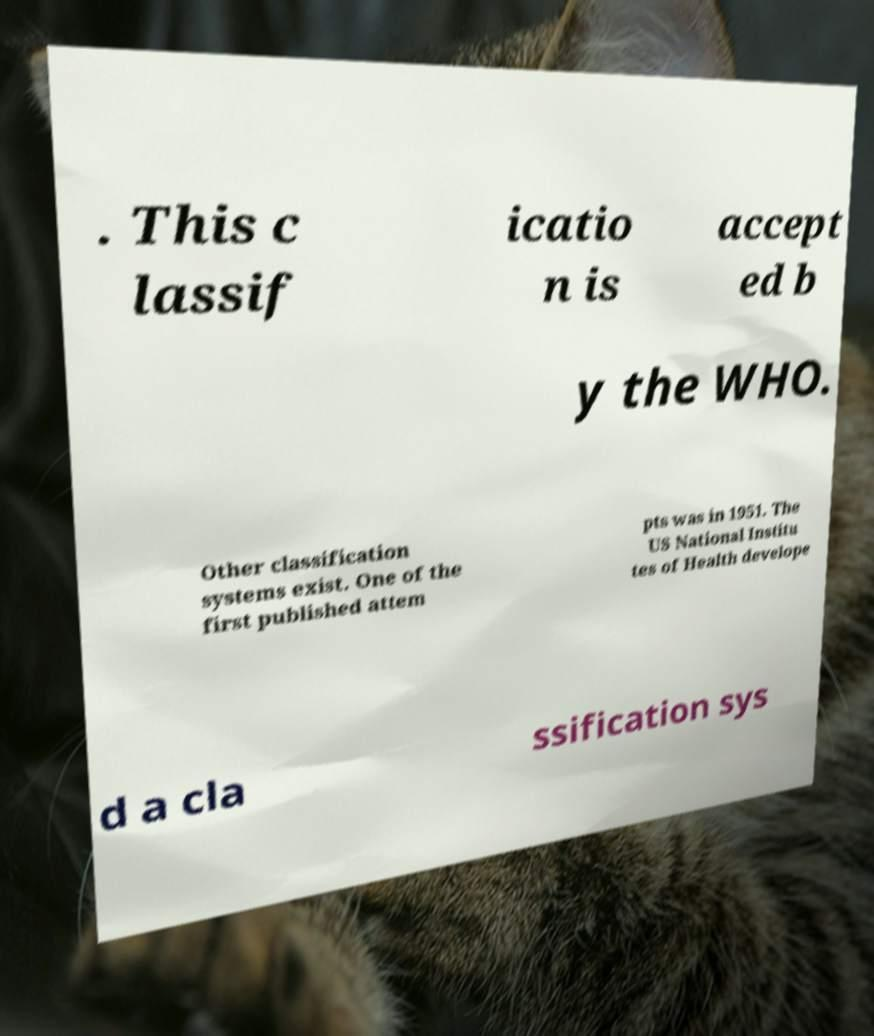I need the written content from this picture converted into text. Can you do that? . This c lassif icatio n is accept ed b y the WHO. Other classification systems exist. One of the first published attem pts was in 1951. The US National Institu tes of Health develope d a cla ssification sys 